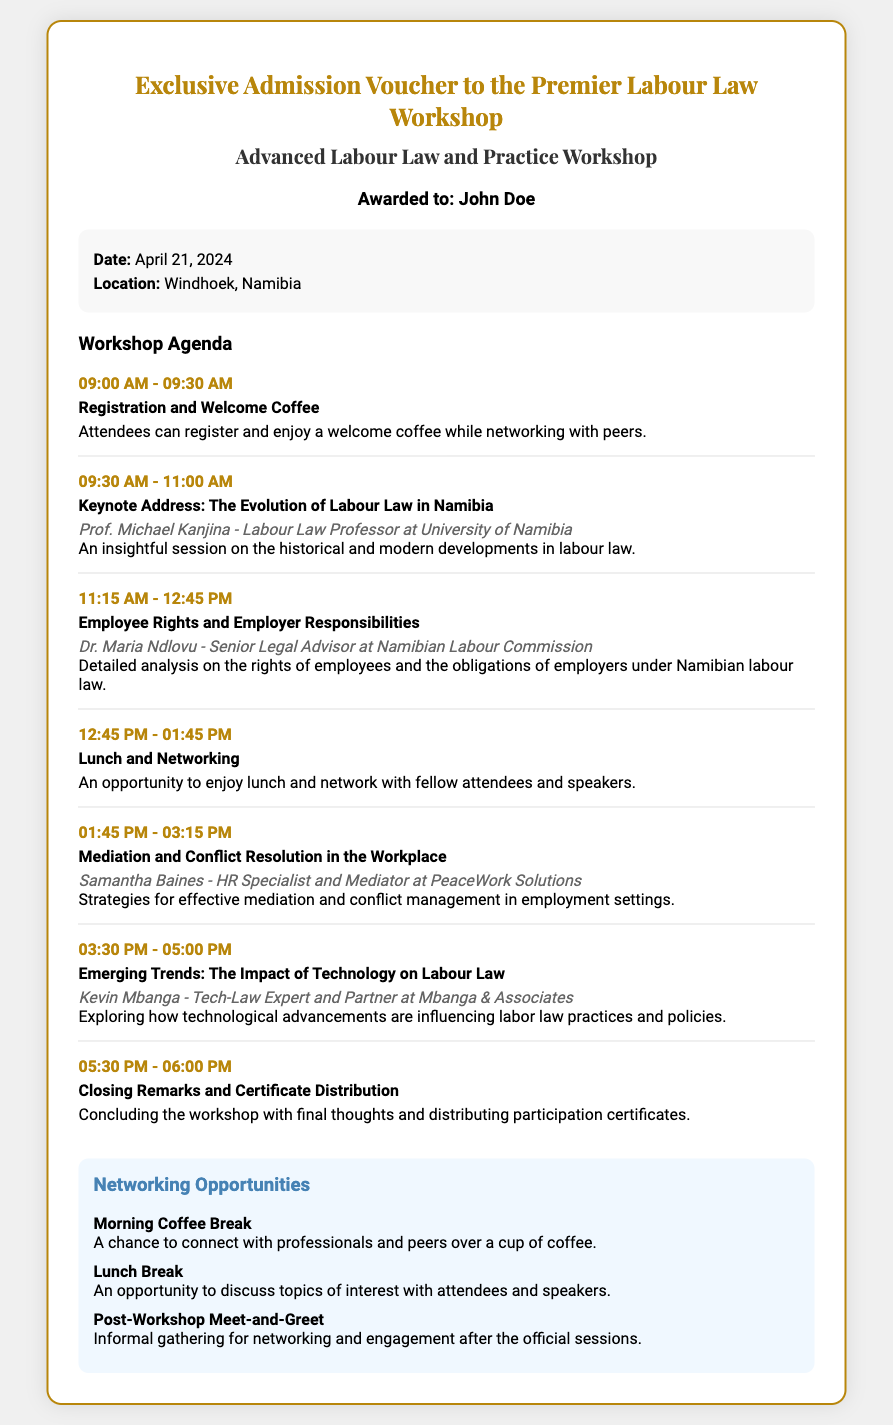What is the date of the workshop? The workshop date is explicitly mentioned in the document under event details.
Answer: April 21, 2024 Where is the workshop located? The location of the workshop is listed in the event details section of the document.
Answer: Windhoek, Namibia Who is the keynote speaker? The keynote speaker's name and details can be found in the agenda section of the document.
Answer: Prof. Michael Kanjina What is the topic of the closing session? The closing session title is provided in the agenda along with its timing.
Answer: Closing Remarks and Certificate Distribution How long is the session on "Employee Rights and Employer Responsibilities"? The duration of this session is specified in the agenda section.
Answer: 1 hour 30 minutes What type of networking opportunity occurs during lunch? This specific networking opportunity is mentioned in the networking section of the document.
Answer: Lunch Break What is the duration of the workshop overall? The agenda provides start and end times that can be used to calculate the total duration of the workshop.
Answer: Approximately 9 hours What is the last session of the day? The title of the last agenda item indicates the final session of the workshop.
Answer: Closing Remarks and Certificate Distribution What type of professional is Samantha Baines? Samantha Baines's professional background is outlined in the agenda.
Answer: HR Specialist and Mediator 